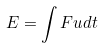Convert formula to latex. <formula><loc_0><loc_0><loc_500><loc_500>E = \int F u d t</formula> 